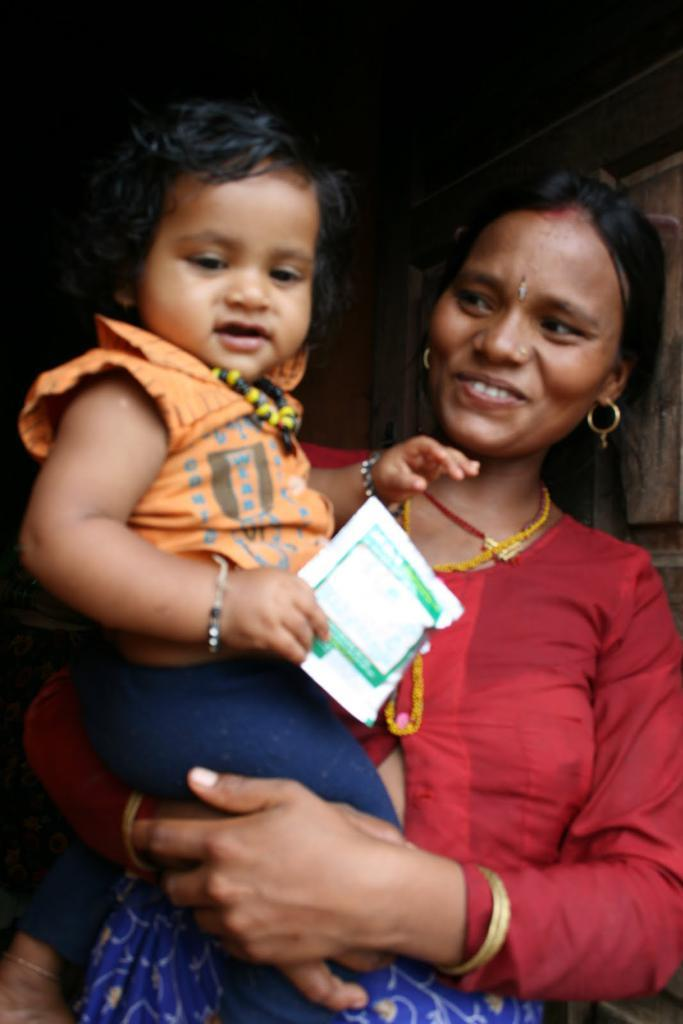Who is the main subject in the image? There is a woman in the image. What is the woman doing in the image? The woman is holding a baby. What is the baby holding in the image? The baby is holding a white color object. Can you see the woman running in the image? No, there is no indication of the woman running in the image. Is the woman wearing a scarf in the image? The provided facts do not mention a scarf, so we cannot determine if the woman is wearing one in the image. 